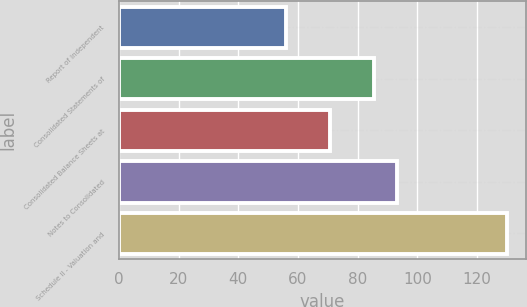<chart> <loc_0><loc_0><loc_500><loc_500><bar_chart><fcel>Report of Independent<fcel>Consolidated Statements of<fcel>Consolidated Balance Sheets at<fcel>Notes to Consolidated<fcel>Schedule II - Valuation and<nl><fcel>56<fcel>85.6<fcel>70.8<fcel>93<fcel>130<nl></chart> 